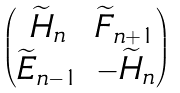<formula> <loc_0><loc_0><loc_500><loc_500>\begin{pmatrix} \widetilde { H } _ { n } & \widetilde { F } _ { n + 1 } \\ \widetilde { E } _ { n - 1 } & - \widetilde { H } _ { n } \end{pmatrix}</formula> 